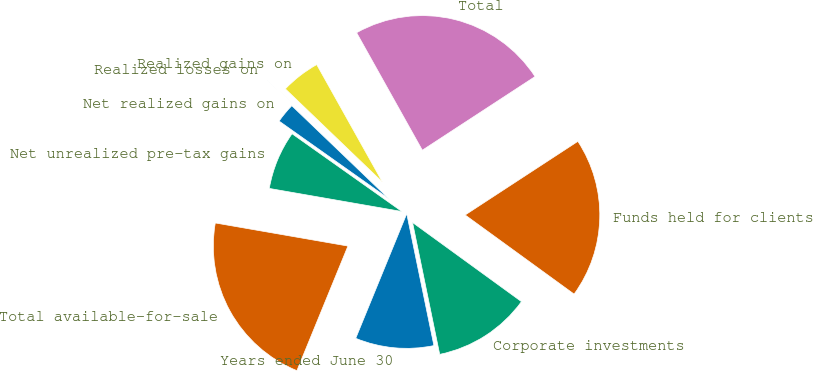<chart> <loc_0><loc_0><loc_500><loc_500><pie_chart><fcel>Years ended June 30<fcel>Corporate investments<fcel>Funds held for clients<fcel>Total<fcel>Realized gains on<fcel>Realized losses on<fcel>Net realized gains on<fcel>Net unrealized pre-tax gains<fcel>Total available-for-sale<nl><fcel>9.42%<fcel>11.77%<fcel>19.21%<fcel>23.91%<fcel>4.71%<fcel>0.01%<fcel>2.36%<fcel>7.06%<fcel>21.56%<nl></chart> 